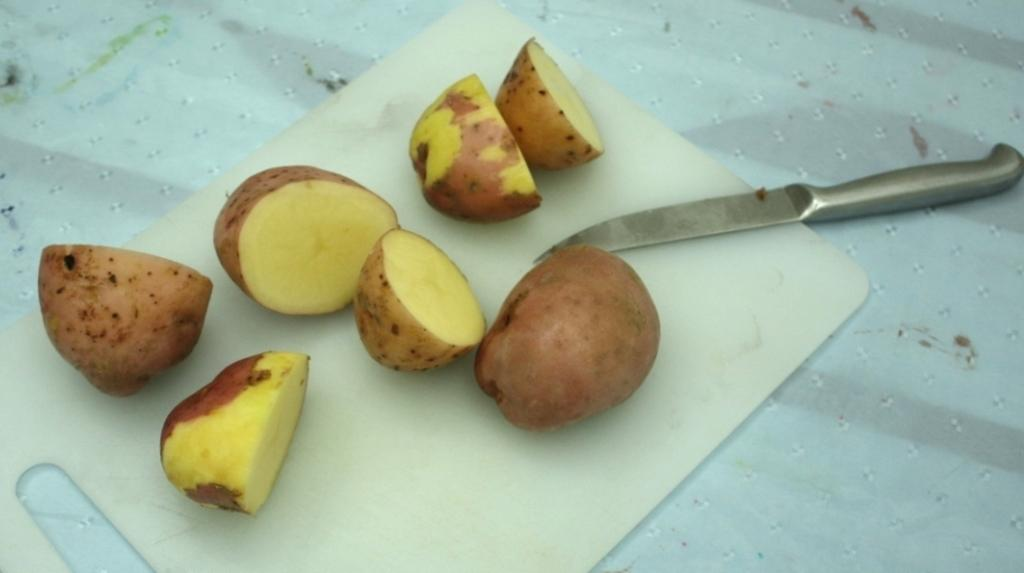What is the main object in the image? There is a white board in the image. What is placed on the white board? There are pieces of potatoes on the white board. What utensil can be seen in the image? There is a silver-colored knife in the image. What act is the potato performing on the white board? The potato is not performing any act on the white board, as it is an inanimate object. 